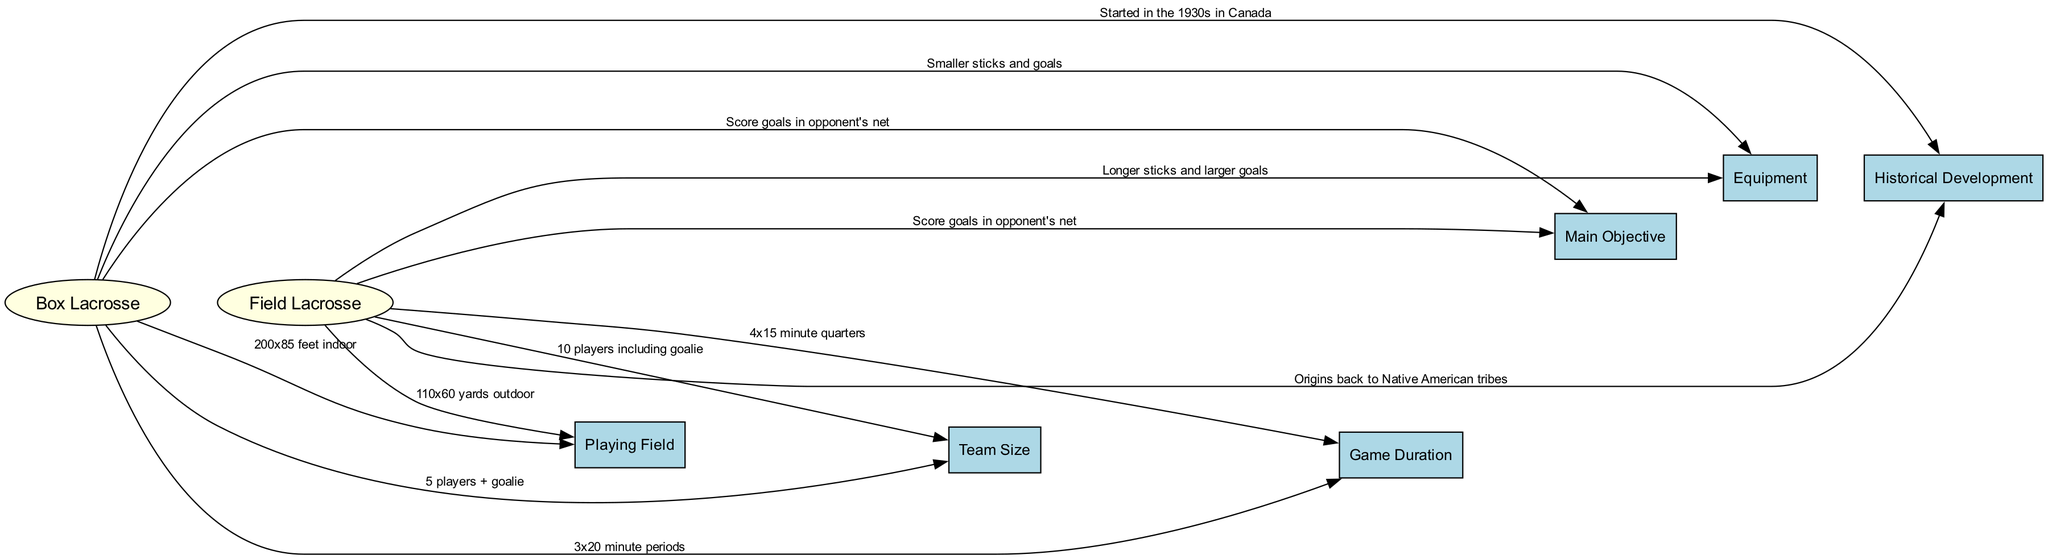What is the size of the playing field for box lacrosse? The diagram states that the playing field for box lacrosse is "200x85 feet indoor." This information is shown in the edge connecting "Box Lacrosse" to "Playing Field."
Answer: 200x85 feet indoor What is the size of the playing field for field lacrosse? According to the diagram, the playing field for field lacrosse is "110x60 yards outdoor." This detail is indicated in the edge from "Field Lacrosse" to "Playing Field."
Answer: 110x60 yards outdoor How many players are on a box lacrosse team including the goalie? The diagram specifies that a box lacrosse team consists of "5 players + goalie," as indicated by the edge connecting "Box Lacrosse" to "Team Size."
Answer: 5 players + goalie What is the game duration for field lacrosse? The diagram shows that the game duration for field lacrosse is "4x15 minute quarters." This information is conveyed through the edge connecting "Field Lacrosse" to "Game Duration."
Answer: 4x15 minute quarters What is the main objective of both box and field lacrosse? The diagram states that the main objective for both playing styles is "Score goals in opponent's net." This is represented by the edges from both "Box Lacrosse" and "Field Lacrosse" to "Main Objective."
Answer: Score goals in opponent's net When did box lacrosse start? The diagram notes that box lacrosse "Started in the 1930s in Canada." This information is found in the edge leading from "Box Lacrosse" to "Historical Development."
Answer: 1930s in Canada What type of sticks and goals are used in box lacrosse? According to the diagram, box lacrosse uses "Smaller sticks and goals." This is indicated by the edge from "Box Lacrosse" to "Equipment."
Answer: Smaller sticks and goals How many players are on a field lacrosse team including the goalie? The diagram indicates that a field lacrosse team has "10 players including goalie," which is shown by the edge from "Field Lacrosse" to "Team Size." The reason it requires checking multiple parts is to ensure we combine the right roles defined for field lacrosse.
Answer: 10 players including goalie What is the historical origin of field lacrosse? The diagram explains that field lacrosse has "Origins back to Native American tribes." This fact is established through the edge that connects "Field Lacrosse" to "Historical Development."
Answer: Origins back to Native American tribes 